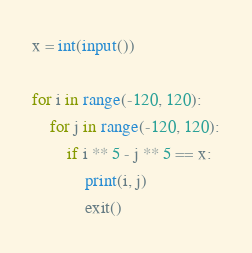Convert code to text. <code><loc_0><loc_0><loc_500><loc_500><_Python_>x = int(input())

for i in range(-120, 120):
    for j in range(-120, 120):
        if i ** 5 - j ** 5 == x:
            print(i, j)
            exit()
</code> 